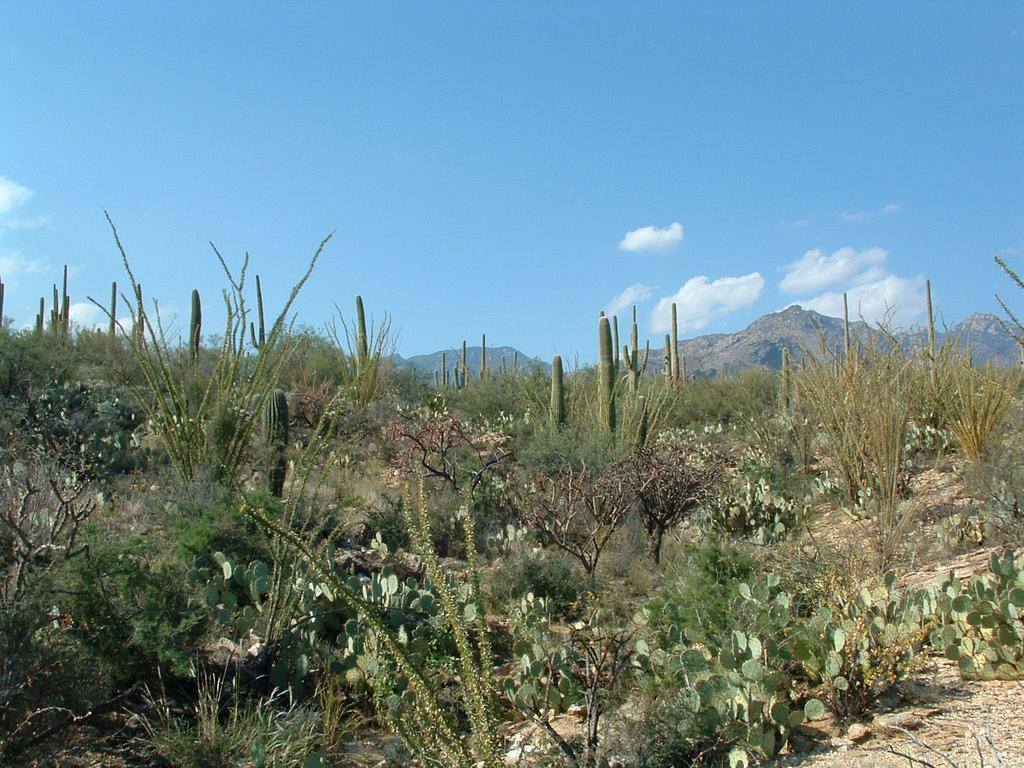What type of vegetation can be seen in the image? There are plants in the image. What type of landscape feature is present in the image? There are hills in the image. What type of ground cover can be seen in the image? There is grass in the image. Can you tell me how many cats are sitting on the seat in the image? There is no seat or cat present in the image. What is the cat's wish in the image? There is no cat present in the image, so it is not possible to determine its wish. 